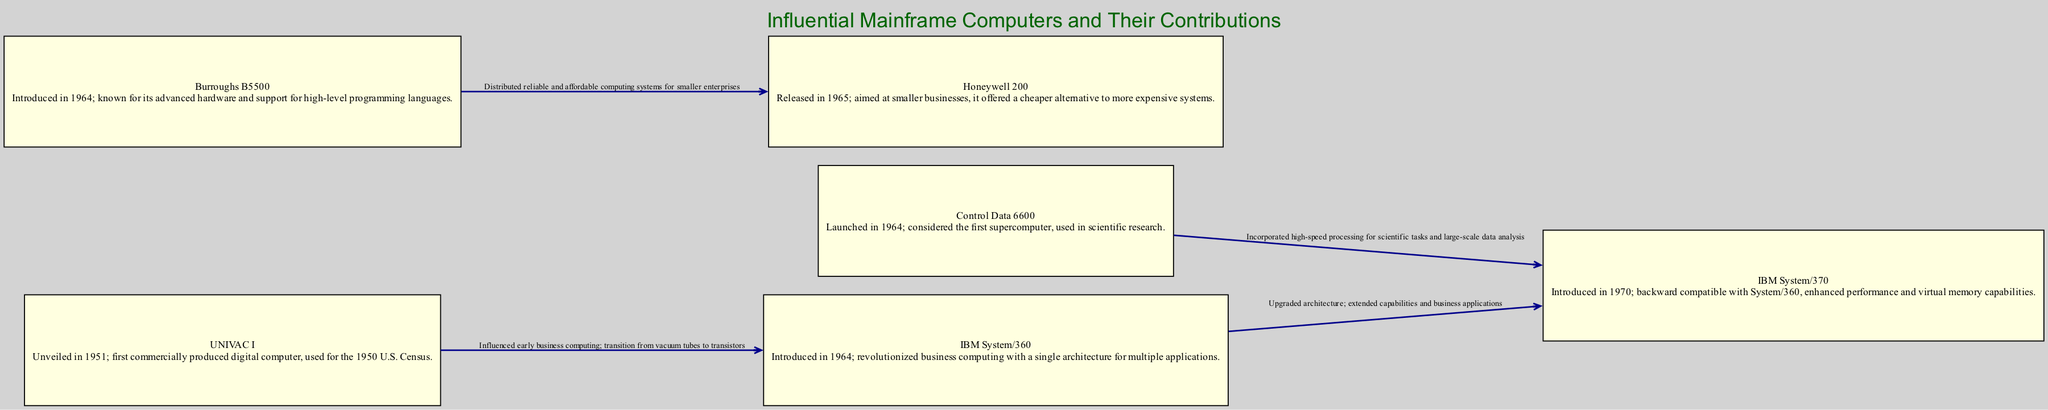What is the title of the diagram? The title of the diagram is explicitly mentioned at the top as "Influential Mainframe Computers and Their Contributions."
Answer: Influential Mainframe Computers and Their Contributions How many mainframe computers are presented in the diagram? By counting the number of nodes listed in the data, there are six mainframe computers included in the diagram.
Answer: 6 What did the UNIVAC I influence? The edge connecting UNIVAC I to IBM System/360 indicates that it influenced early business computing and represented the transition from vacuum tubes to transistors.
Answer: Early business computing What year was the Control Data 6600 launched? The description of the Control Data 6600 node notes that it was launched in the year 1964.
Answer: 1964 Which model is known as the first supercomputer? The description of the Control Data 6600 specifically states that it is considered the first supercomputer.
Answer: Control Data 6600 What relationship does the IBM System/370 have with the IBM System/360? The edge from IBM System/360 to IBM System/370 indicates that the System/370 had an upgraded architecture and extended capabilities building on the System/360's foundation.
Answer: Upgraded architecture Which two models are connected in the diagram that emphasize smaller enterprise computing? The Burroughs B5500 and Honeywell 200 are connected, suggesting that they provided reliable and affordable computing systems for smaller businesses.
Answer: Burroughs B5500 and Honeywell 200 What was the primary market aim of the Honeywell 200 model? The description indicates that the Honeywell 200 offered a cheaper alternative aimed at smaller businesses.
Answer: Smaller businesses What enhancement did the IBM System/370 bring to virtual memory capabilities? The description of the IBM System/370 notes that it enhanced performance and included virtual memory capabilities as part of its features.
Answer: Enhanced performance and virtual memory capabilities 